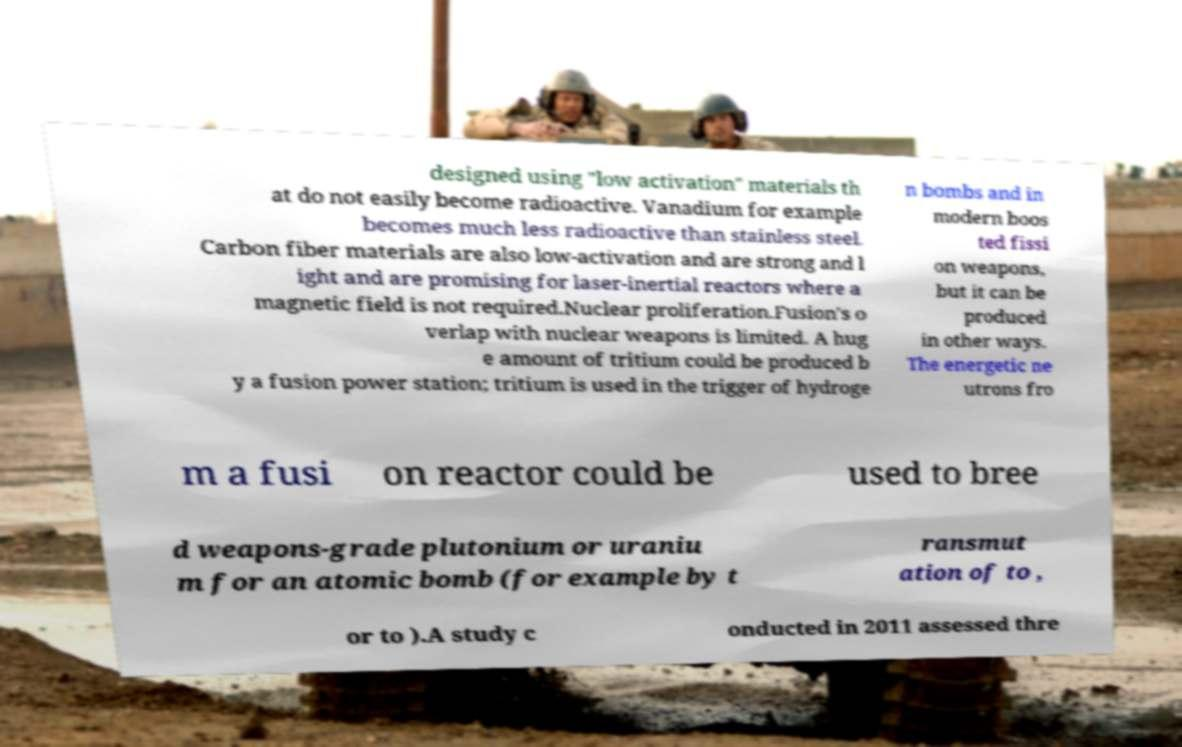Can you accurately transcribe the text from the provided image for me? designed using "low activation" materials th at do not easily become radioactive. Vanadium for example becomes much less radioactive than stainless steel. Carbon fiber materials are also low-activation and are strong and l ight and are promising for laser-inertial reactors where a magnetic field is not required.Nuclear proliferation.Fusion's o verlap with nuclear weapons is limited. A hug e amount of tritium could be produced b y a fusion power station; tritium is used in the trigger of hydroge n bombs and in modern boos ted fissi on weapons, but it can be produced in other ways. The energetic ne utrons fro m a fusi on reactor could be used to bree d weapons-grade plutonium or uraniu m for an atomic bomb (for example by t ransmut ation of to , or to ).A study c onducted in 2011 assessed thre 